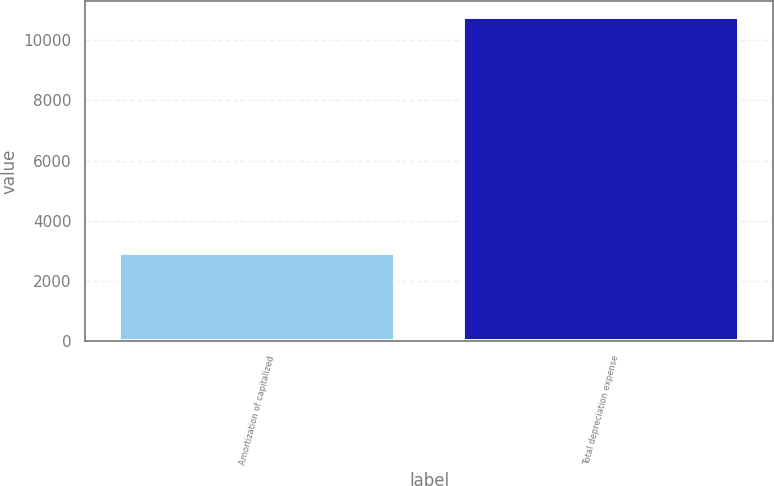<chart> <loc_0><loc_0><loc_500><loc_500><bar_chart><fcel>Amortization of capitalized<fcel>Total depreciation expense<nl><fcel>2938<fcel>10763<nl></chart> 